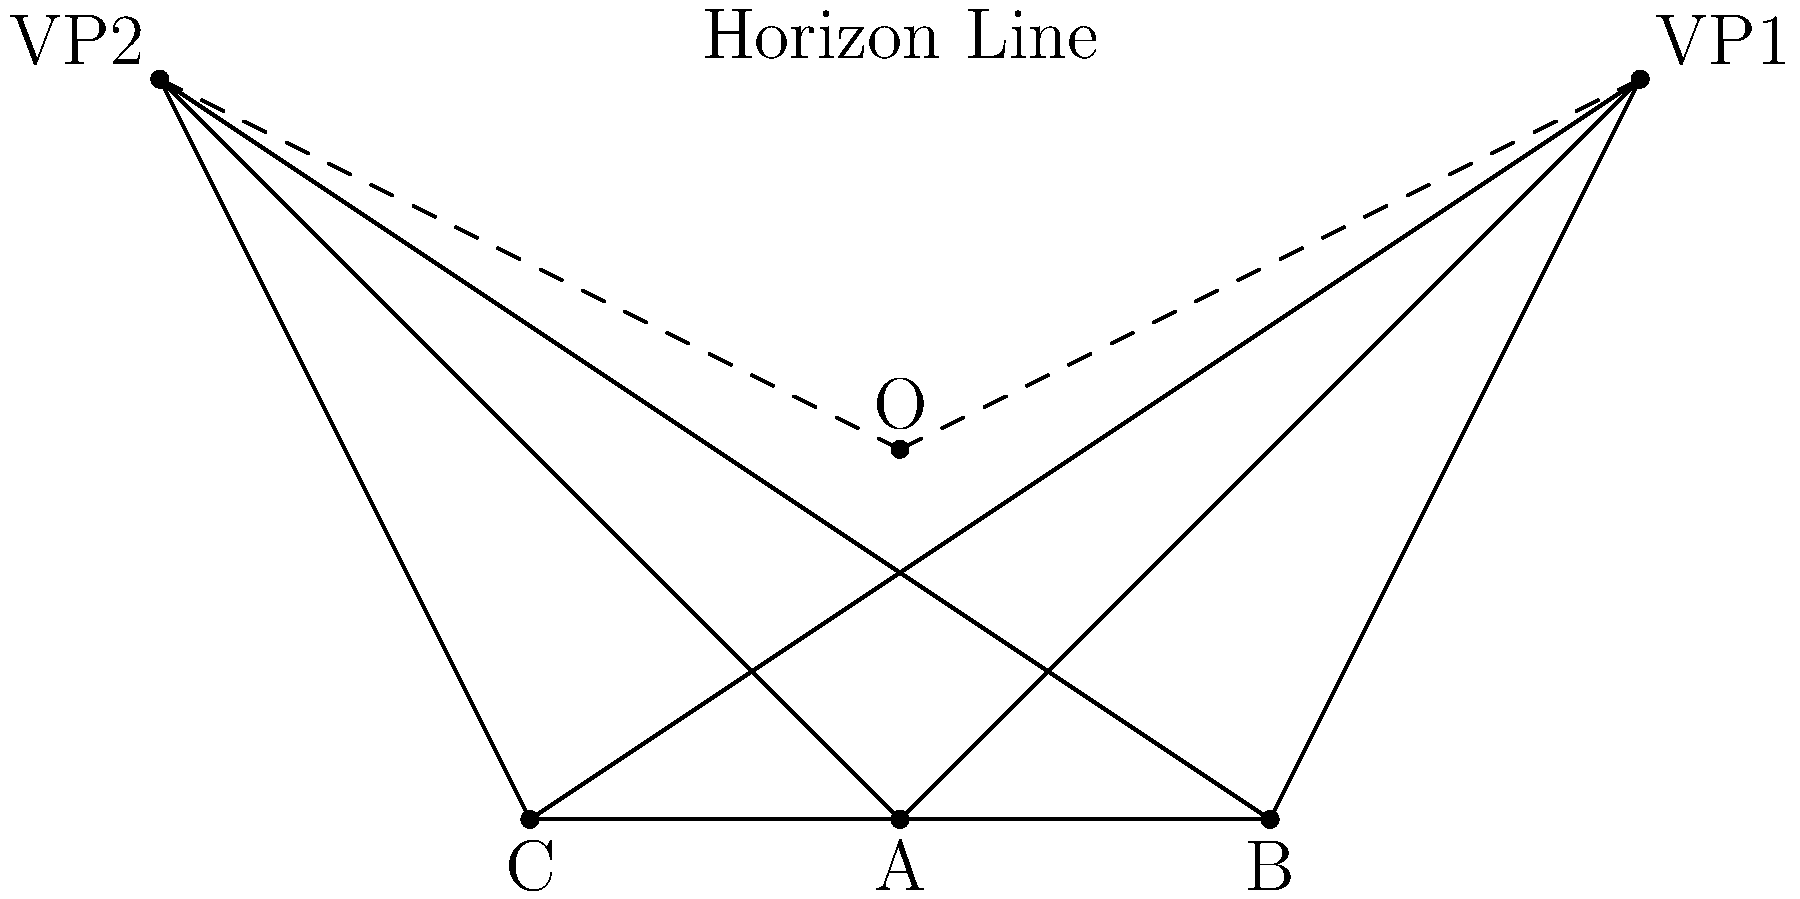In a complex cityscape drawing, you've established a two-point perspective with vanishing points VP1 and VP2. If the base of a building is represented by triangle ABC, and the viewer's eye level (horizon line) is above the building, how would you determine the true shape and proportions of the building's roof? Explain your approach using the principles of perspective drawing. To determine the true shape and proportions of the building's roof in a two-point perspective cityscape drawing, follow these steps:

1. Identify the vanishing points (VP1 and VP2) and the horizon line, which represents the viewer's eye level.

2. Recognize that the base of the building (triangle ABC) is below the horizon line, indicating that we're looking down at the building.

3. Draw vertical lines from each corner of the base (A, B, and C) upwards. These represent the edges of the building.

4. Determine the height of the building by choosing a point on one of these vertical lines. Let's call this point D (not shown in the diagram).

5. From point D, draw lines to both vanishing points (VP1 and VP2). These lines represent the edges of the roof.

6. Where these lines intersect the other vertical lines from the base will give you the other corners of the roof. Let's call these points E and F (not shown in the diagram).

7. Connect D, E, and F to complete the roof shape.

8. To find the true shape of the roof:
   a. Draw a horizontal line from point D parallel to the horizon line.
   b. From points E and F, draw lines perpendicular to this horizontal line.
   c. The resulting shape on this horizontal plane will show the true proportions of the roof without perspective distortion.

9. Measure the sides of this "true shape" to determine the actual proportions of the roof.

10. Use these measurements to accurately depict details, textures, or additional structures on the roof in your cityscape drawing.

This method allows you to maintain accurate proportions and perspective in your complex cityscape, ensuring that the building's roof is correctly represented in the two-point perspective system.
Answer: Draw vertical lines from base corners, connect roof points to vanishing points, and use a horizontal plane at roof level to determine true shape and proportions. 